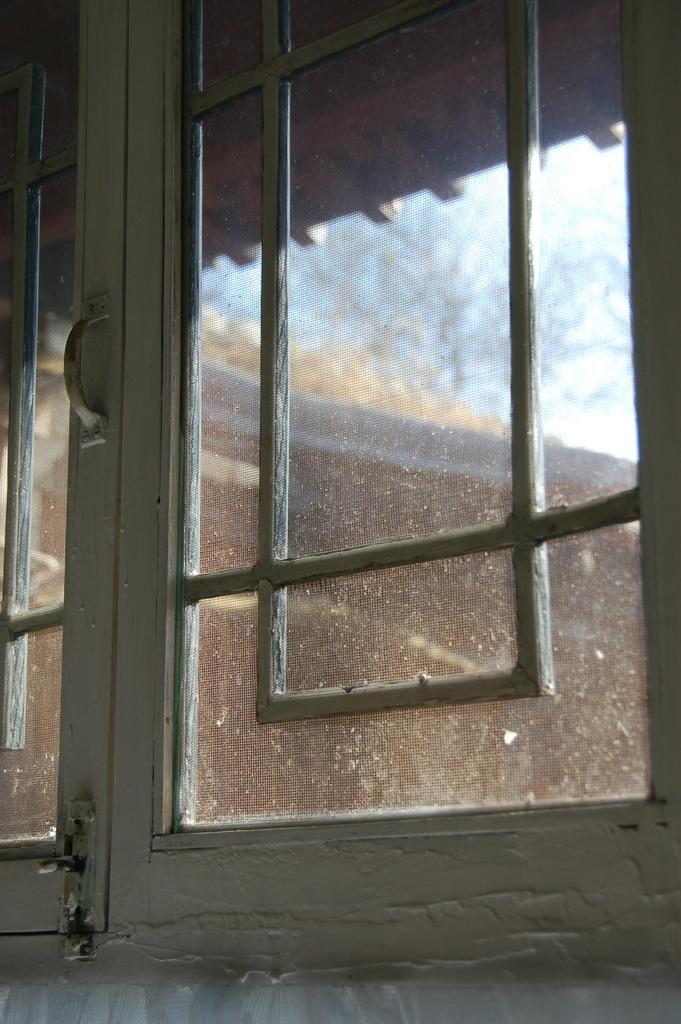What is the focus of the image? The image is a zoomed in picture. What can be seen in the foreground of the image? There is a window in the foreground of the image. What is visible through the window? The sky and a building are visible through the window. How many nails can be seen in the image? There are no nails present in the image. What is the profit of the building visible through the window? The image does not provide information about the profit of the building visible through the window. 